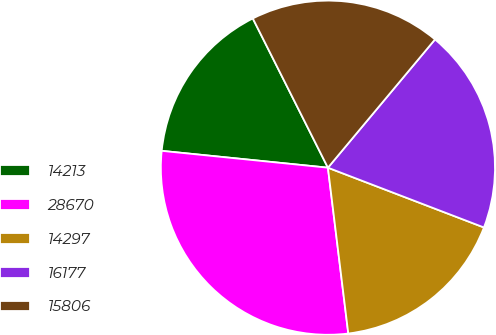Convert chart. <chart><loc_0><loc_0><loc_500><loc_500><pie_chart><fcel>14213<fcel>28670<fcel>14297<fcel>16177<fcel>15806<nl><fcel>15.97%<fcel>28.55%<fcel>17.23%<fcel>19.75%<fcel>18.49%<nl></chart> 